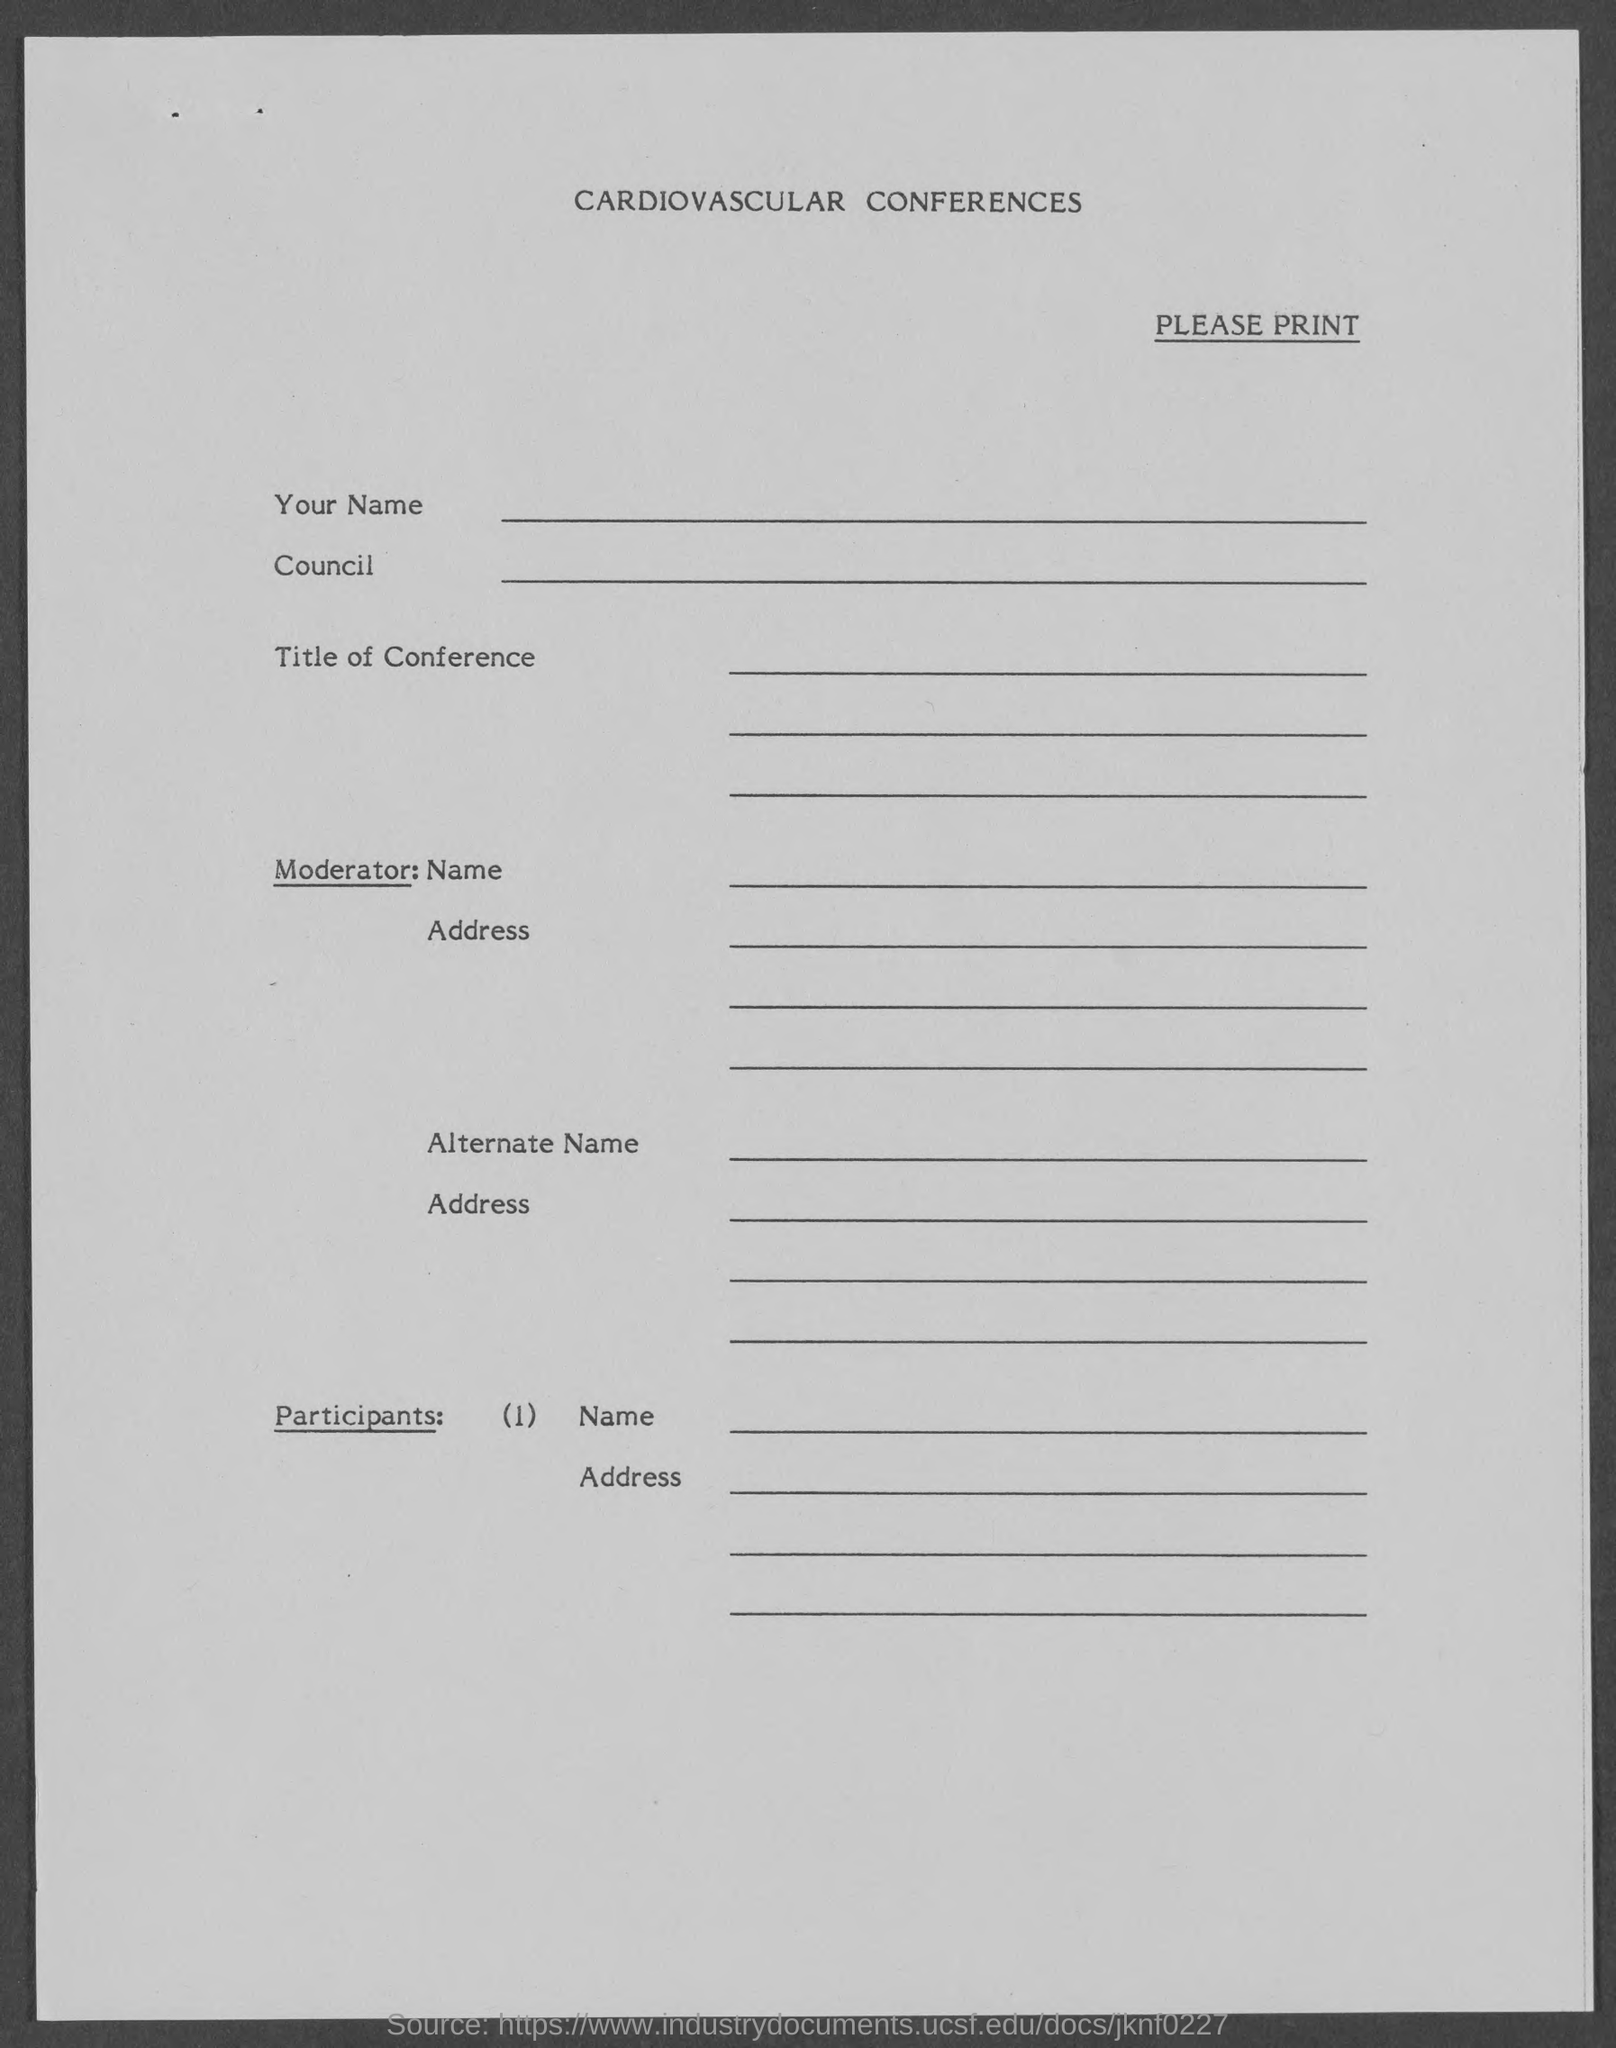Mention a couple of crucial points in this snapshot. The document title is "Cardiovascular Conferences. 